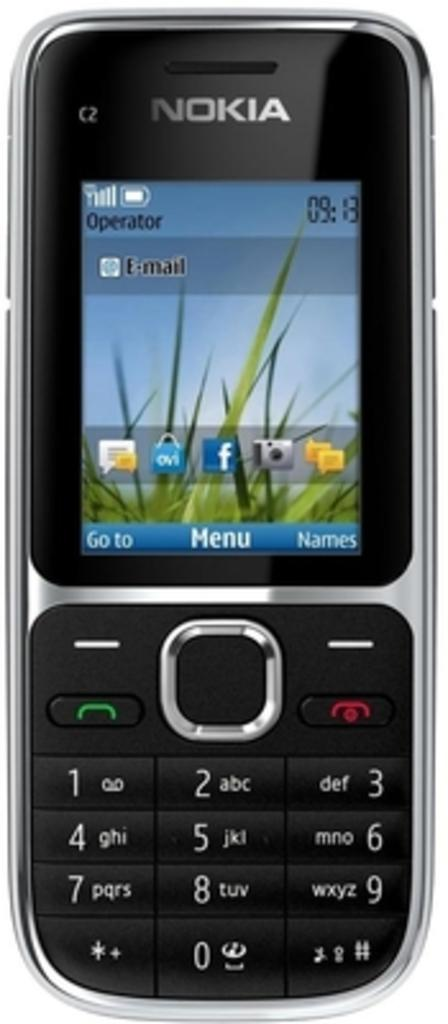Provide a one-sentence caption for the provided image. A Nokia phone shows the time is 9:13. 